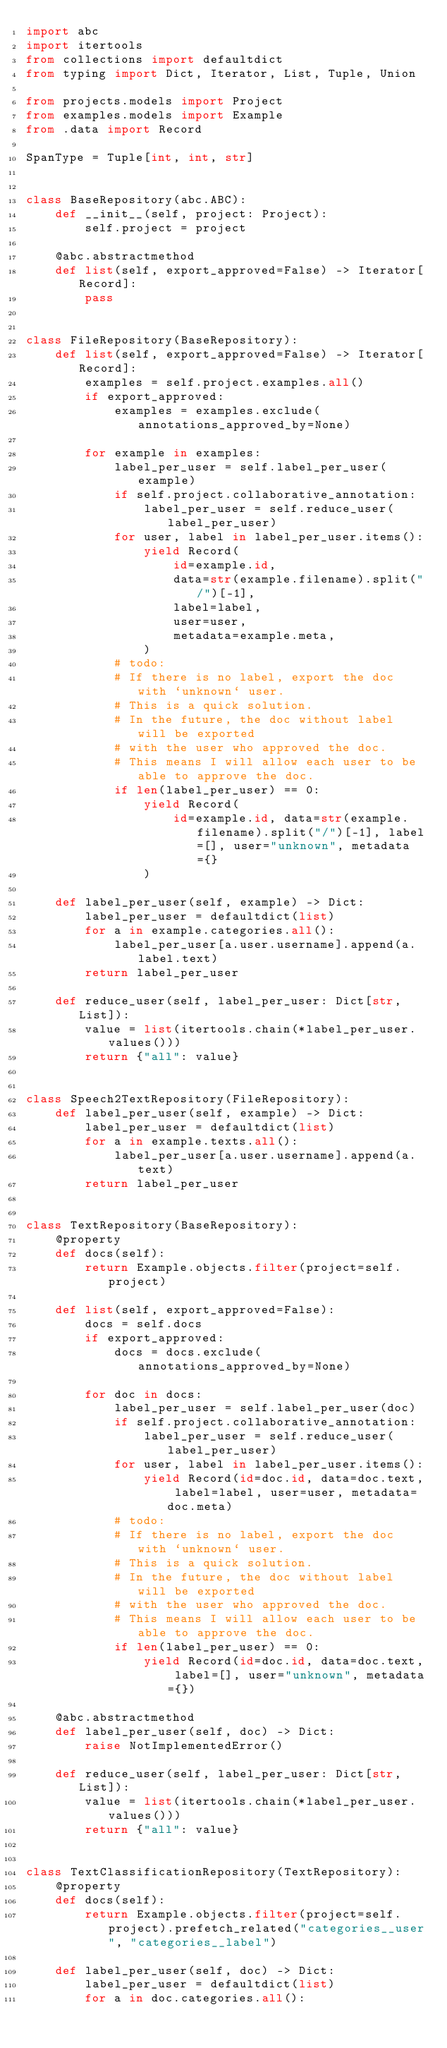<code> <loc_0><loc_0><loc_500><loc_500><_Python_>import abc
import itertools
from collections import defaultdict
from typing import Dict, Iterator, List, Tuple, Union

from projects.models import Project
from examples.models import Example
from .data import Record

SpanType = Tuple[int, int, str]


class BaseRepository(abc.ABC):
    def __init__(self, project: Project):
        self.project = project

    @abc.abstractmethod
    def list(self, export_approved=False) -> Iterator[Record]:
        pass


class FileRepository(BaseRepository):
    def list(self, export_approved=False) -> Iterator[Record]:
        examples = self.project.examples.all()
        if export_approved:
            examples = examples.exclude(annotations_approved_by=None)

        for example in examples:
            label_per_user = self.label_per_user(example)
            if self.project.collaborative_annotation:
                label_per_user = self.reduce_user(label_per_user)
            for user, label in label_per_user.items():
                yield Record(
                    id=example.id,
                    data=str(example.filename).split("/")[-1],
                    label=label,
                    user=user,
                    metadata=example.meta,
                )
            # todo:
            # If there is no label, export the doc with `unknown` user.
            # This is a quick solution.
            # In the future, the doc without label will be exported
            # with the user who approved the doc.
            # This means I will allow each user to be able to approve the doc.
            if len(label_per_user) == 0:
                yield Record(
                    id=example.id, data=str(example.filename).split("/")[-1], label=[], user="unknown", metadata={}
                )

    def label_per_user(self, example) -> Dict:
        label_per_user = defaultdict(list)
        for a in example.categories.all():
            label_per_user[a.user.username].append(a.label.text)
        return label_per_user

    def reduce_user(self, label_per_user: Dict[str, List]):
        value = list(itertools.chain(*label_per_user.values()))
        return {"all": value}


class Speech2TextRepository(FileRepository):
    def label_per_user(self, example) -> Dict:
        label_per_user = defaultdict(list)
        for a in example.texts.all():
            label_per_user[a.user.username].append(a.text)
        return label_per_user


class TextRepository(BaseRepository):
    @property
    def docs(self):
        return Example.objects.filter(project=self.project)

    def list(self, export_approved=False):
        docs = self.docs
        if export_approved:
            docs = docs.exclude(annotations_approved_by=None)

        for doc in docs:
            label_per_user = self.label_per_user(doc)
            if self.project.collaborative_annotation:
                label_per_user = self.reduce_user(label_per_user)
            for user, label in label_per_user.items():
                yield Record(id=doc.id, data=doc.text, label=label, user=user, metadata=doc.meta)
            # todo:
            # If there is no label, export the doc with `unknown` user.
            # This is a quick solution.
            # In the future, the doc without label will be exported
            # with the user who approved the doc.
            # This means I will allow each user to be able to approve the doc.
            if len(label_per_user) == 0:
                yield Record(id=doc.id, data=doc.text, label=[], user="unknown", metadata={})

    @abc.abstractmethod
    def label_per_user(self, doc) -> Dict:
        raise NotImplementedError()

    def reduce_user(self, label_per_user: Dict[str, List]):
        value = list(itertools.chain(*label_per_user.values()))
        return {"all": value}


class TextClassificationRepository(TextRepository):
    @property
    def docs(self):
        return Example.objects.filter(project=self.project).prefetch_related("categories__user", "categories__label")

    def label_per_user(self, doc) -> Dict:
        label_per_user = defaultdict(list)
        for a in doc.categories.all():</code> 